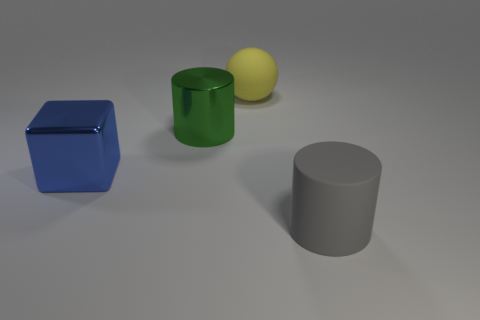There is a large blue cube left of the object that is right of the large yellow rubber object; are there any gray matte things that are behind it?
Give a very brief answer. No. There is a large shiny object on the right side of the metallic cube; is its shape the same as the matte thing in front of the large yellow sphere?
Offer a very short reply. Yes. What is the material of the gray object that is the same size as the yellow matte sphere?
Provide a succinct answer. Rubber. Does the cylinder left of the large ball have the same material as the big object to the right of the yellow ball?
Your answer should be compact. No. The matte thing that is the same size as the gray rubber cylinder is what shape?
Make the answer very short. Sphere. How many other things are there of the same color as the large rubber cylinder?
Keep it short and to the point. 0. What color is the cylinder in front of the blue block?
Give a very brief answer. Gray. How many other objects are the same material as the gray thing?
Ensure brevity in your answer.  1. Are there more big rubber things that are behind the large blue shiny block than gray rubber objects that are behind the gray thing?
Keep it short and to the point. Yes. What number of big yellow rubber things are left of the large gray cylinder?
Ensure brevity in your answer.  1. 